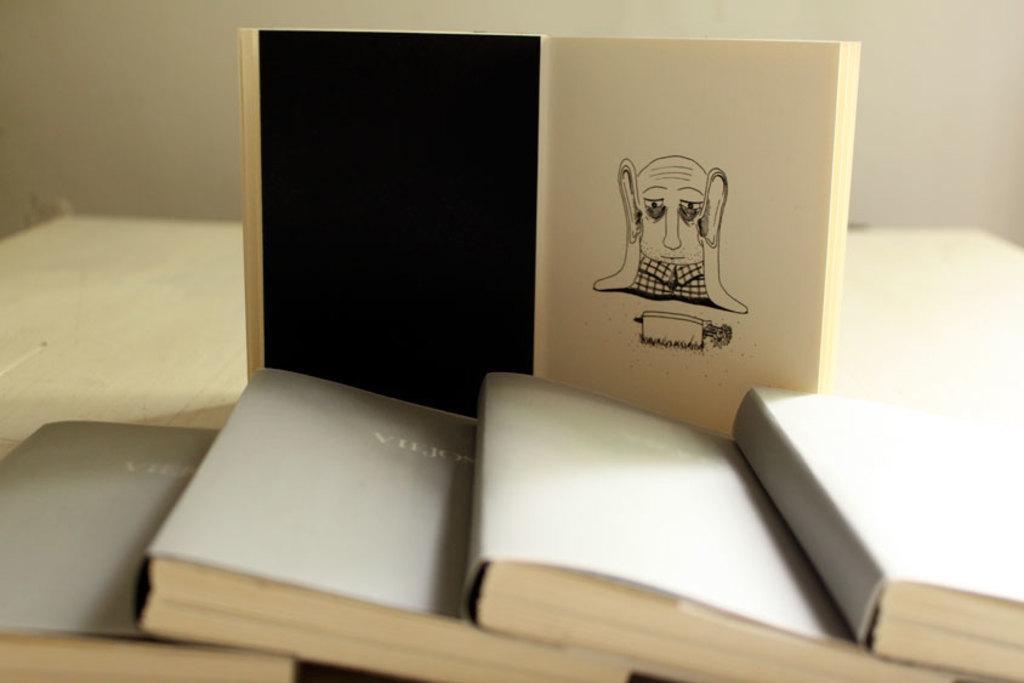Describe this image in one or two sentences. In this image at the bottom there are some books, and in the background also there is another book. On the book there is some drawing and at the bottom there is a table, and in the background there is a wall. 